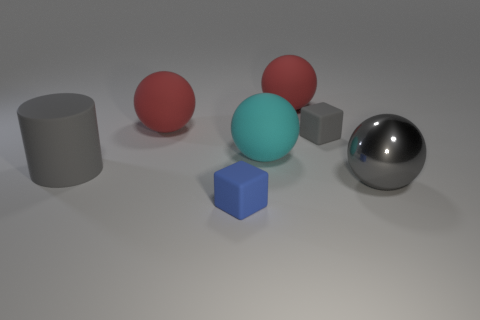What is the shape of the tiny matte object that is the same color as the large metal thing?
Offer a very short reply. Cube. The small matte object in front of the gray thing that is left of the small matte block in front of the matte cylinder is what color?
Give a very brief answer. Blue. How many gray matte objects have the same shape as the big shiny object?
Keep it short and to the point. 0. There is a sphere to the right of the gray matte object on the right side of the cyan thing; what size is it?
Provide a short and direct response. Large. Is the size of the gray shiny sphere the same as the blue thing?
Provide a short and direct response. No. Is there a small gray thing that is on the right side of the gray block behind the big ball that is right of the small gray object?
Provide a short and direct response. No. How big is the gray rubber cylinder?
Give a very brief answer. Large. How many objects have the same size as the rubber cylinder?
Make the answer very short. 4. What is the material of the other small thing that is the same shape as the blue matte object?
Offer a very short reply. Rubber. What shape is the gray object that is both in front of the cyan ball and to the right of the cyan rubber object?
Provide a succinct answer. Sphere. 